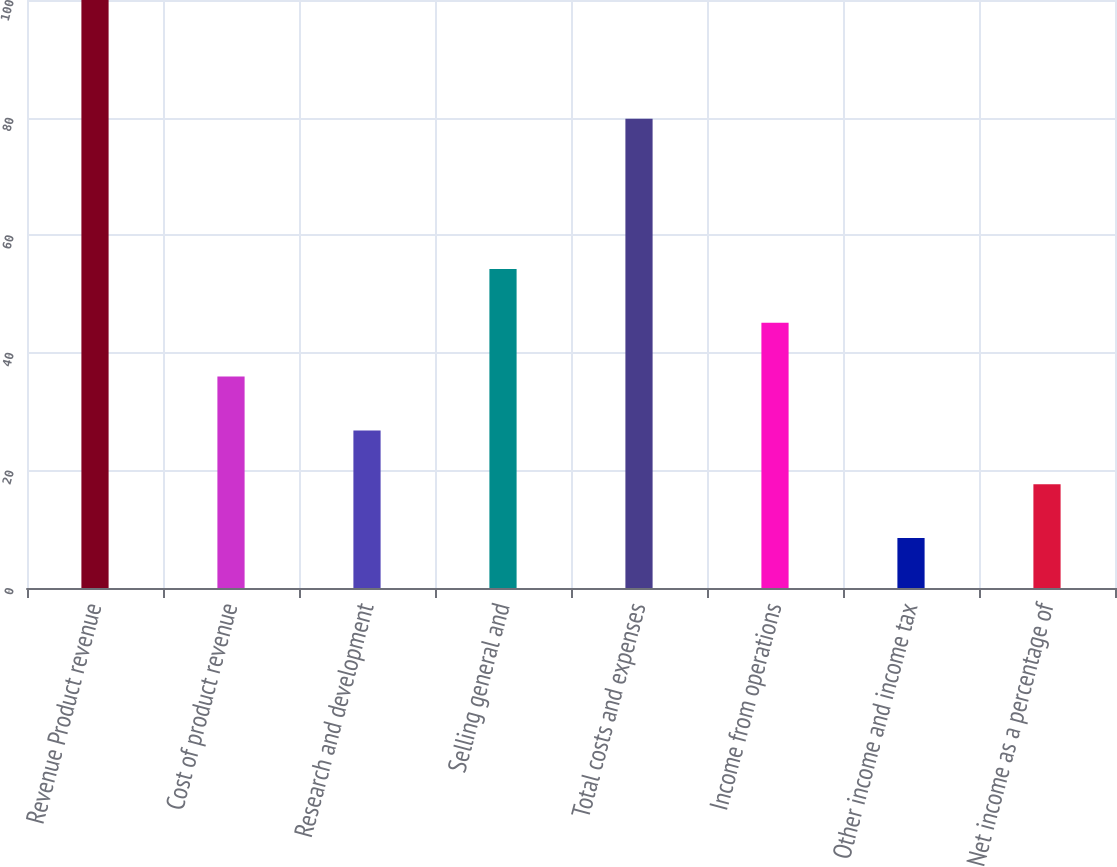<chart> <loc_0><loc_0><loc_500><loc_500><bar_chart><fcel>Revenue Product revenue<fcel>Cost of product revenue<fcel>Research and development<fcel>Selling general and<fcel>Total costs and expenses<fcel>Income from operations<fcel>Other income and income tax<fcel>Net income as a percentage of<nl><fcel>100<fcel>35.95<fcel>26.8<fcel>54.25<fcel>79.8<fcel>45.1<fcel>8.5<fcel>17.65<nl></chart> 